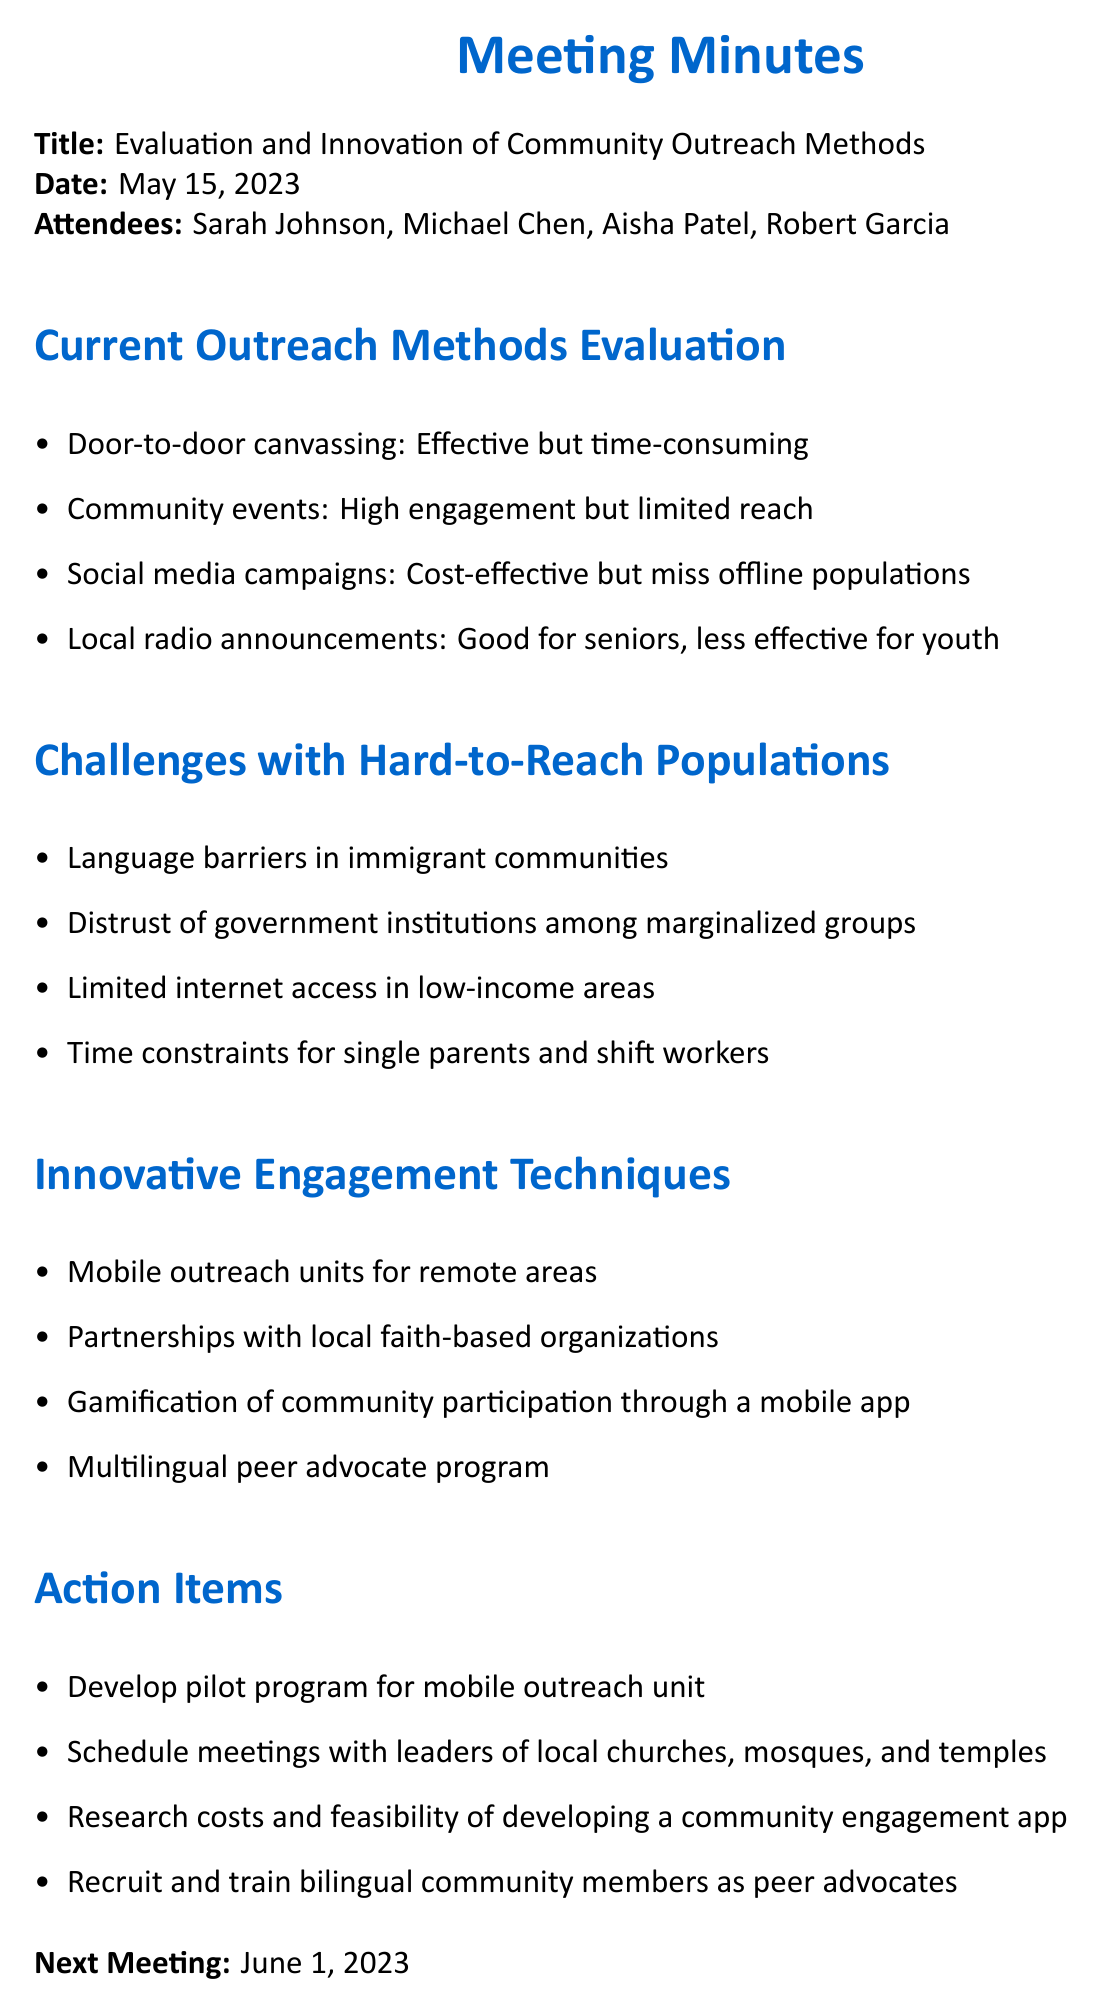What is the title of the meeting? The title of the meeting is provided at the beginning of the document.
Answer: Evaluation and Innovation of Community Outreach Methods Who is the Outreach Coordinator? The name of the Outreach Coordinator is listed in the attendees section of the document.
Answer: Michael Chen What is one challenge with hard-to-reach populations? Challenges listed in the document include several points related to hard-to-reach populations.
Answer: Language barriers in immigrant communities What innovative engagement technique involves remote areas? The document specifies several innovative techniques, one of which pertains to remote areas.
Answer: Mobile outreach units for remote areas When is the next meeting scheduled? The date of the next meeting is noted at the end of the document.
Answer: June 1, 2023 What is one action item decided during the meeting? Action items are a key section in the document, outlining follow-up tasks.
Answer: Develop pilot program for mobile outreach unit How many attendees were there at the meeting? The number of individuals present is mentioned in the attendee list.
Answer: Four What type of outreach method is described as effective but time-consuming? The document categorizes various outreach methods, detailing their effectiveness.
Answer: Door-to-door canvassing What does the document suggest for engaging marginalized groups? The innovative engagement techniques section outlines methods aimed at better engagement.
Answer: Partnerships with local faith-based organizations 